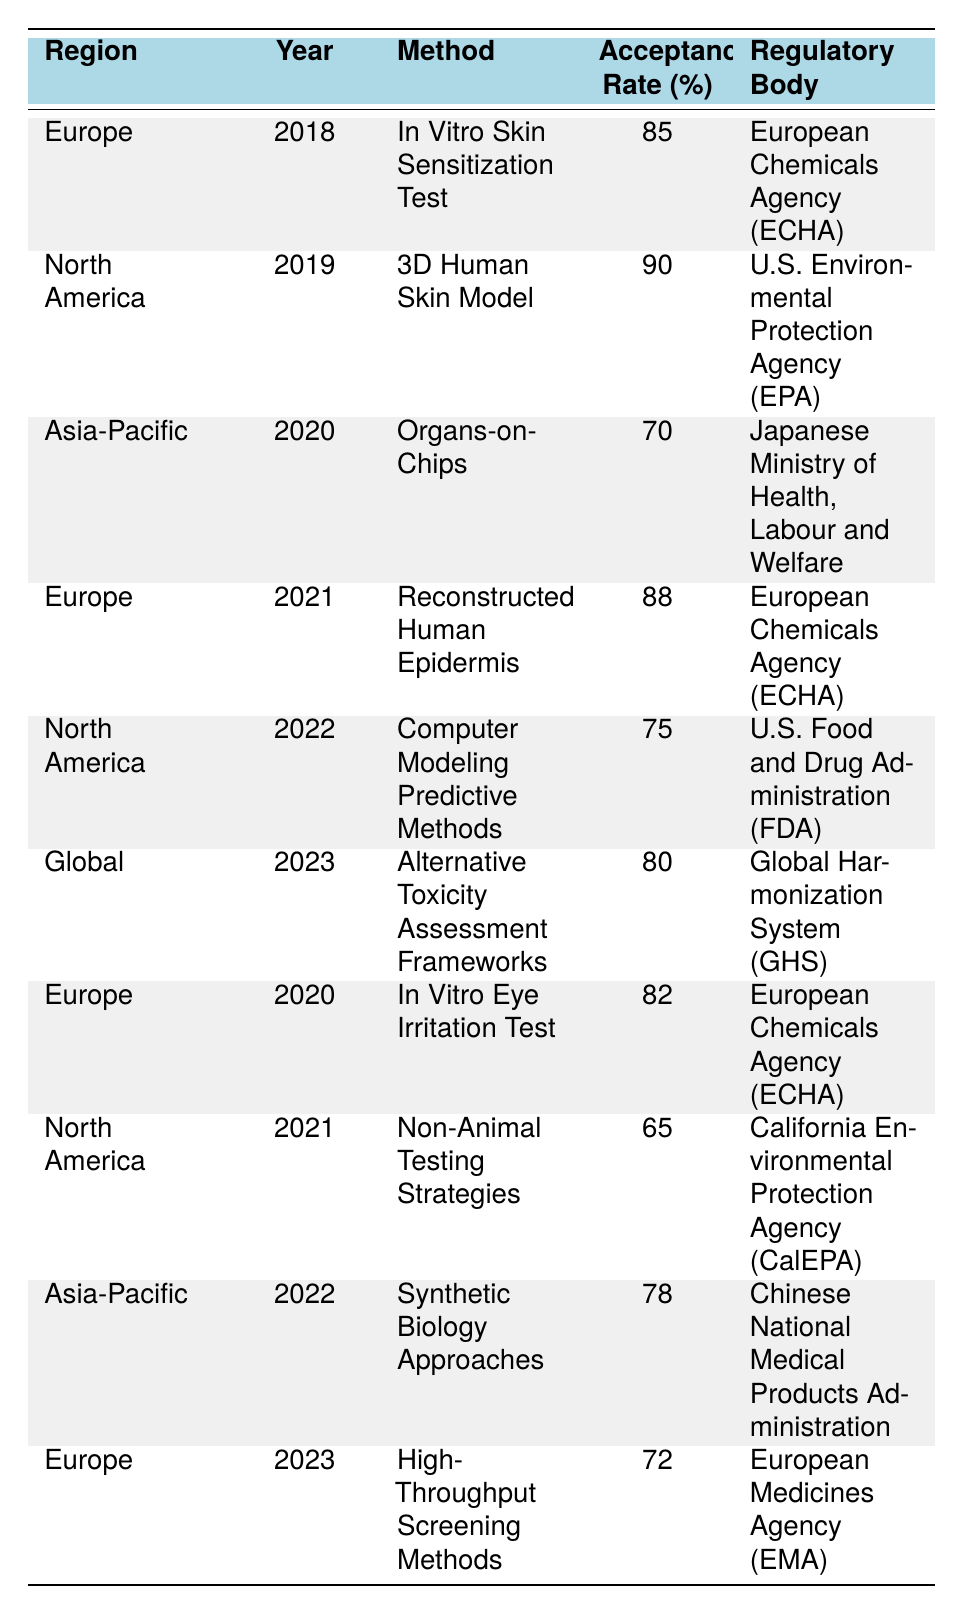What was the acceptance rate for the 3D Human Skin Model in North America? The table indicates that in 2019, the 3D Human Skin Model had an acceptance rate of 90% in North America.
Answer: 90% Which method had the lowest acceptance rate in North America during the specified years? The lowest acceptance rate in North America was for Non-Animal Testing Strategies in 2021 with a rate of 65%.
Answer: 65% What is the acceptance rate for the In Vitro Eye Irritation Test in Europe? According to the table, the In Vitro Eye Irritation Test had an acceptance rate of 82% in Europe in 2020.
Answer: 82% How many alternative methods had an acceptance rate of 80% or higher in the table? The methods with acceptance rates of 80% or higher are: In Vitro Skin Sensitization Test (85%), 3D Human Skin Model (90%), Reconstructed Human Epidermis (88%), and Alternative Toxicity Assessment Frameworks (80%). This totals four methods.
Answer: 4 What is the average acceptance rate of the alternative methods listed for the year 2022? The acceptance rates for 2022 are 75% (North America: Computer Modeling Predictive Methods) and 78% (Asia-Pacific: Synthetic Biology Approaches). Summing these gives 75 + 78 = 153. The average is 153/2 = 76.5.
Answer: 76.5 Was the acceptance rate for Organs-on-Chips in the Asia-Pacific region higher than that for Non-Animal Testing Strategies in North America? Organs-on-Chips had an acceptance rate of 70% in Asia-Pacific in 2020, while Non-Animal Testing Strategies had an acceptance rate of 65% in North America in 2021. Therefore, 70% is higher than 65%.
Answer: Yes In which year and region did the method with the highest acceptance rate occur, and what was that rate? The highest acceptance rate is 90%, which occurred in 2019 in North America for the 3D Human Skin Model.
Answer: 90% (2019, North America) What trends can be observed from the acceptance rates of methods in Europe from 2020 to 2023? The acceptance rates for Europe from 2020 to 2023 are: 82% (2020: In Vitro Eye Irritation Test), 88% (2021: Reconstructed Human Epidermis), and 72% (2023: High-Throughput Screening Methods). The trend shows an increase from 2020 to 2021, followed by a decrease in 2023.
Answer: Increase then decrease Which regulatory body approved the method with the highest acceptance rate overall? The method with the highest acceptance rate is the 3D Human Skin Model, approved by the U.S. Environmental Protection Agency (EPA) in 2019.
Answer: U.S. Environmental Protection Agency (EPA) 